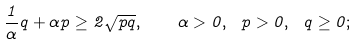<formula> <loc_0><loc_0><loc_500><loc_500>\frac { 1 } { \alpha } q + \alpha p \geq 2 \sqrt { p q } , \quad \alpha > 0 , \ p > 0 , \ q \geq 0 ;</formula> 